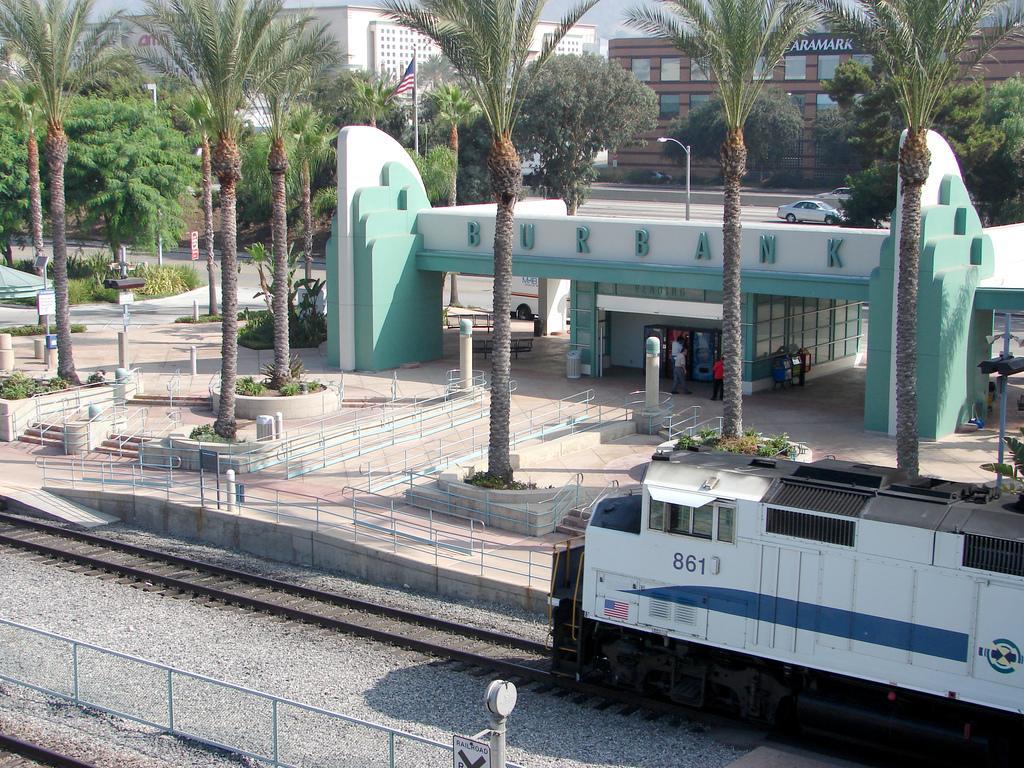How would you summarize this image in a sentence or two? In this image, we can see buildings, trees, lights, poles and there is a flag and we can see people, plants, boards, railings, a car on the road and there are tracks and there is a train. At the top, there is sky. 